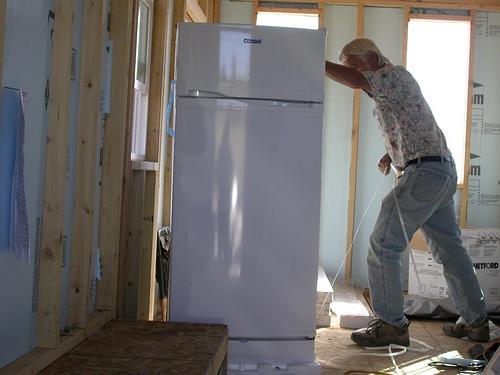Is the complete wall up?
Concise answer only. No. What is the man trying to move?
Keep it brief. Refrigerator. What kind of shoes is he wearing?
Short answer required. Boots. What color is the fridge?
Keep it brief. White. What is the boy have under his feet?
Concise answer only. Floor. How many people in the shot?
Answer briefly. 1. 